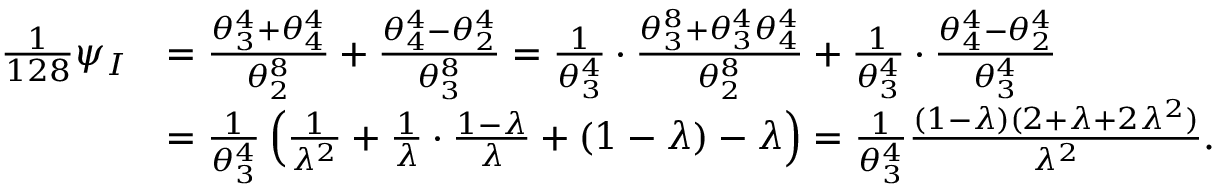Convert formula to latex. <formula><loc_0><loc_0><loc_500><loc_500>\begin{array} { r l } { \frac { 1 } { 1 2 8 } \psi _ { I } } & { = \frac { \theta _ { 3 } ^ { 4 } + \theta _ { 4 } ^ { 4 } } { \theta _ { 2 } ^ { 8 } } + \frac { \theta _ { 4 } ^ { 4 } - \theta _ { 2 } ^ { 4 } } { \theta _ { 3 } ^ { 8 } } = \frac { 1 } { \theta _ { 3 } ^ { 4 } } \cdot \frac { \theta _ { 3 } ^ { 8 } + \theta _ { 3 } ^ { 4 } \theta _ { 4 } ^ { 4 } } { \theta _ { 2 } ^ { 8 } } + \frac { 1 } { \theta _ { 3 } ^ { 4 } } \cdot \frac { \theta _ { 4 } ^ { 4 } - \theta _ { 2 } ^ { 4 } } { \theta _ { 3 } ^ { 4 } } } \\ & { = \frac { 1 } { \theta _ { 3 } ^ { 4 } } \left ( \frac { 1 } { \lambda ^ { 2 } } + \frac { 1 } { \lambda } \cdot \frac { 1 - \lambda } { \lambda } + ( 1 - \lambda ) - \lambda \right ) = \frac { 1 } { \theta _ { 3 } ^ { 4 } } \frac { ( 1 - \lambda ) ( 2 + \lambda + 2 \lambda ^ { 2 } ) } { \lambda ^ { 2 } } . } \end{array}</formula> 